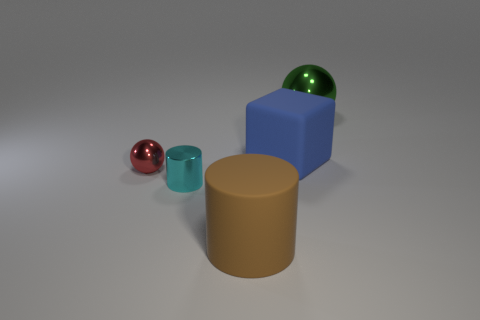What is the big thing in front of the metallic ball that is in front of the metallic thing on the right side of the blue cube made of?
Make the answer very short. Rubber. Is the thing on the left side of the cyan metallic thing made of the same material as the tiny cylinder?
Offer a terse response. Yes. What number of red things are the same size as the cyan cylinder?
Provide a succinct answer. 1. Is the number of big shiny spheres that are behind the large sphere greater than the number of cyan metallic cylinders right of the tiny cyan cylinder?
Ensure brevity in your answer.  No. Is there another big blue object that has the same shape as the big metal object?
Your response must be concise. No. There is a ball that is in front of the matte thing that is behind the tiny red shiny object; what size is it?
Offer a terse response. Small. What shape is the matte thing behind the small thing in front of the ball that is in front of the green metallic object?
Your answer should be very brief. Cube. There is a blue block that is made of the same material as the brown cylinder; what is its size?
Keep it short and to the point. Large. Is the number of shiny things greater than the number of small metal cylinders?
Your answer should be very brief. Yes. There is a block that is the same size as the green shiny thing; what is its material?
Make the answer very short. Rubber. 